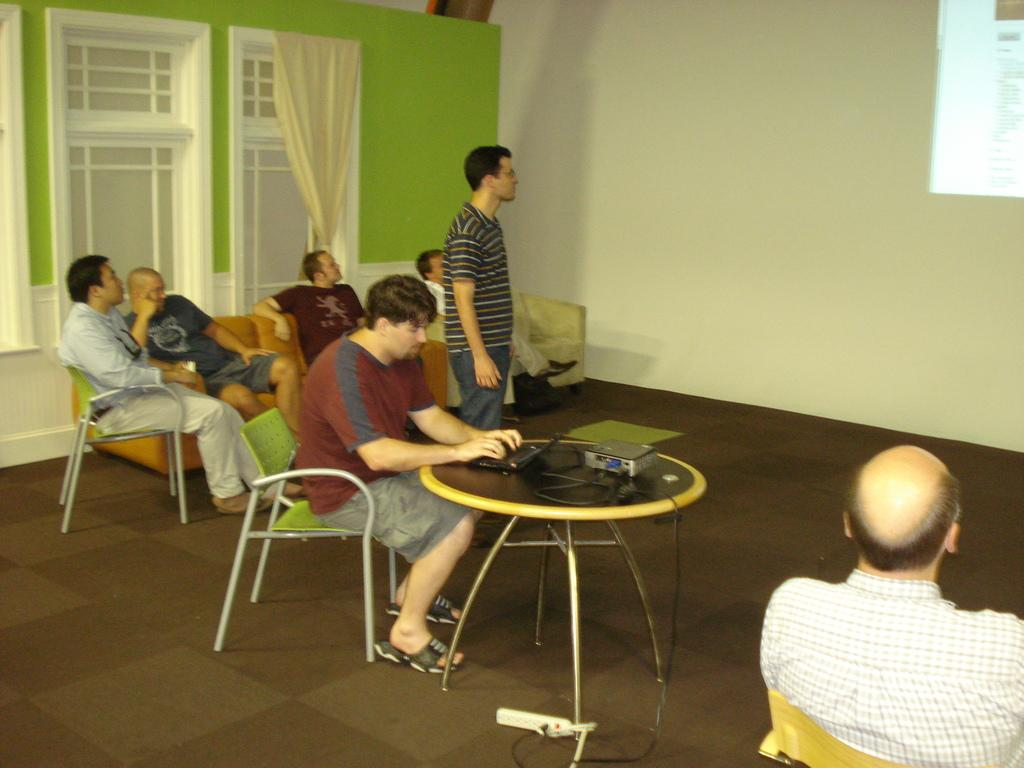What are the people in the image doing? The people in the image are seated on chairs. What is the man on the table doing? The man on the table is working on a laptop. What is the other man doing in the image? The other man is standing and looking at the light on the wall. What type of vegetable is being used as a toy by the people in the image? There are no vegetables or toys present in the image. How many trucks can be seen in the image? There are no trucks visible in the image. 